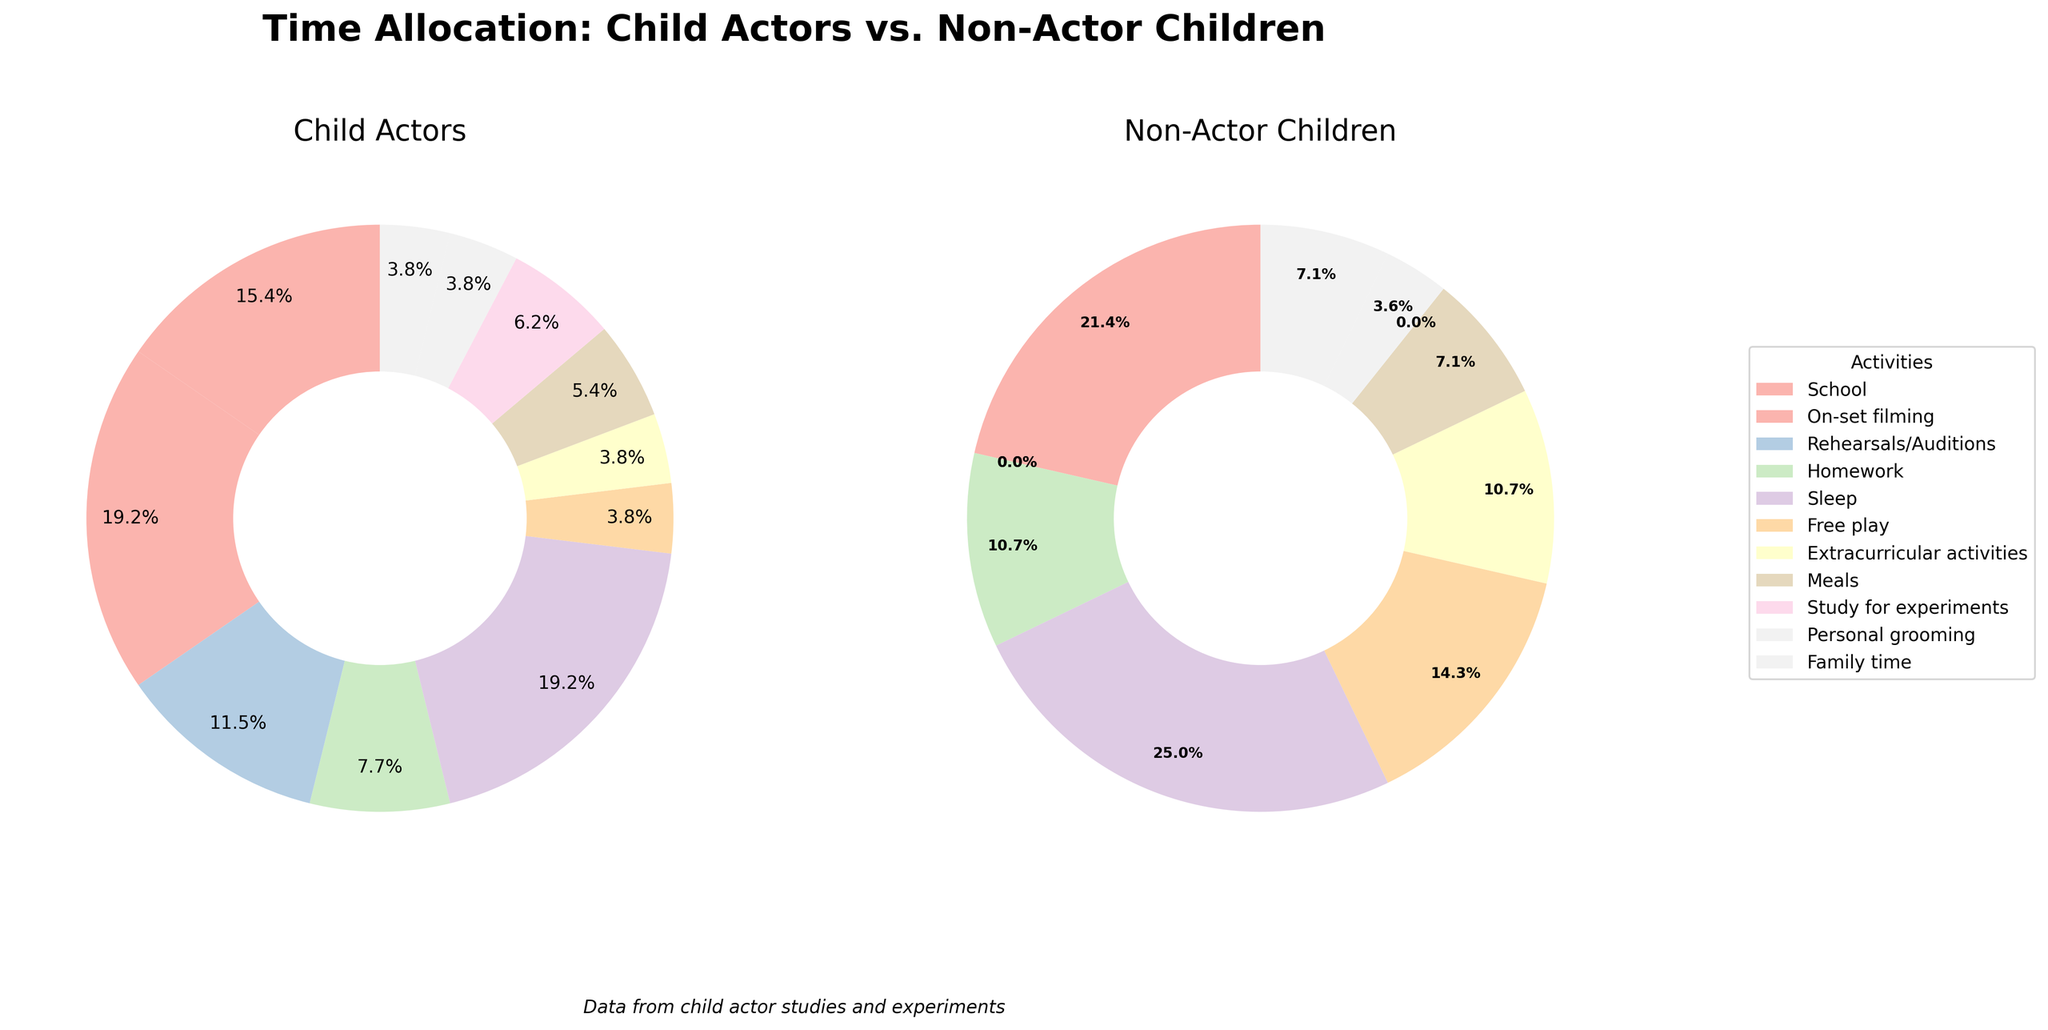Which group spends more time on school activities? The pie chart shows that non-actor children spend 30% of their time on school activities, while child actors spend only 20%.
Answer: Non-Actor Children How much more time do child actors spend on on-set filming compared to non-actor children? Since non-actor children spend 0% of their time on on-set filming and child actors spend 25%, the difference is 25%.
Answer: 25% Which activity takes up the largest portion of child actors' daily schedule? The largest section in the child actors' pie chart represents sleep, which is 25%.
Answer: Sleep When it comes to free play, how does the time allocation between child actors and non-actor children compare? Child actors spend 5% on free play while non-actor children spend 20%, showing that non-actor children spend significantly more time on free play.
Answer: Non-Actor Children spend more What percentage of daily activities is devoted to meals for non-actor children compared to child actors? Non-actor children allocate 10% to meals, while child actors allocate 7%, making non-actor children spend 3% more on meals.
Answer: Non-Actor Children spend 3% more How does the time spent on extracurricular activities differ between the two groups? The pie chart indicates that non-actor children spend 15% on extracurricular activities, whereas child actors spend only 5%.
Answer: Non-Actor Children spend 10% more What is the combined percentage of time spent on school and homework for non-actor children? Non-actor children spend 30% on school and 15% on homework, making the combined total 45%.
Answer: 45% Between child actors and non-actor children, who spends more time on personal grooming? Both groups spend an equal amount of time on personal grooming, which is 5%.
Answer: Equal Add the time spent on study for experiments and rehearsals/auditions for child actors. What is the total percentage? Child actors spend 8% on study for experiments and 15% on rehearsals/auditions. Combined, this is 8% + 15% = 23%.
Answer: 23% What activity do child actors spend 10% of their time on, and how does it compare to non-actor children in the same activity? Child actors spend 10% on homework, whereas non-actor children spend 15% on homework, showing that non-actor children spend 5% more on homework.
Answer: Homework; Non-Actor Children spend 5% more 